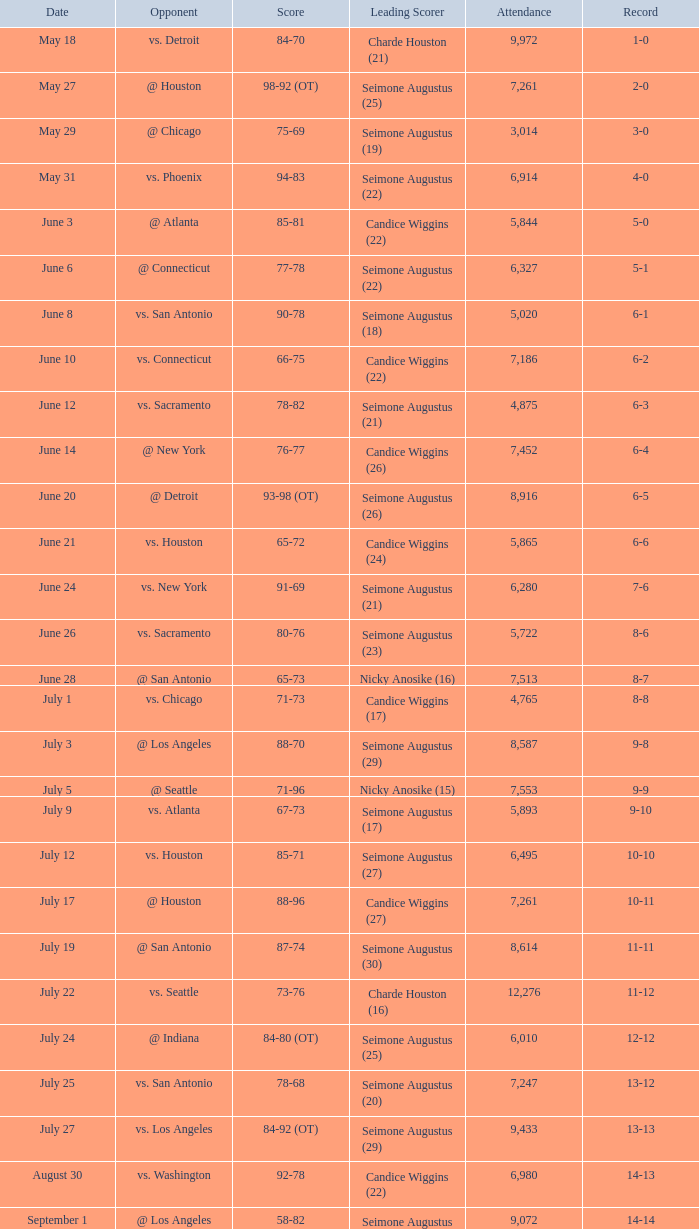Which Attendance has a Date of september 7? 7999.0. 